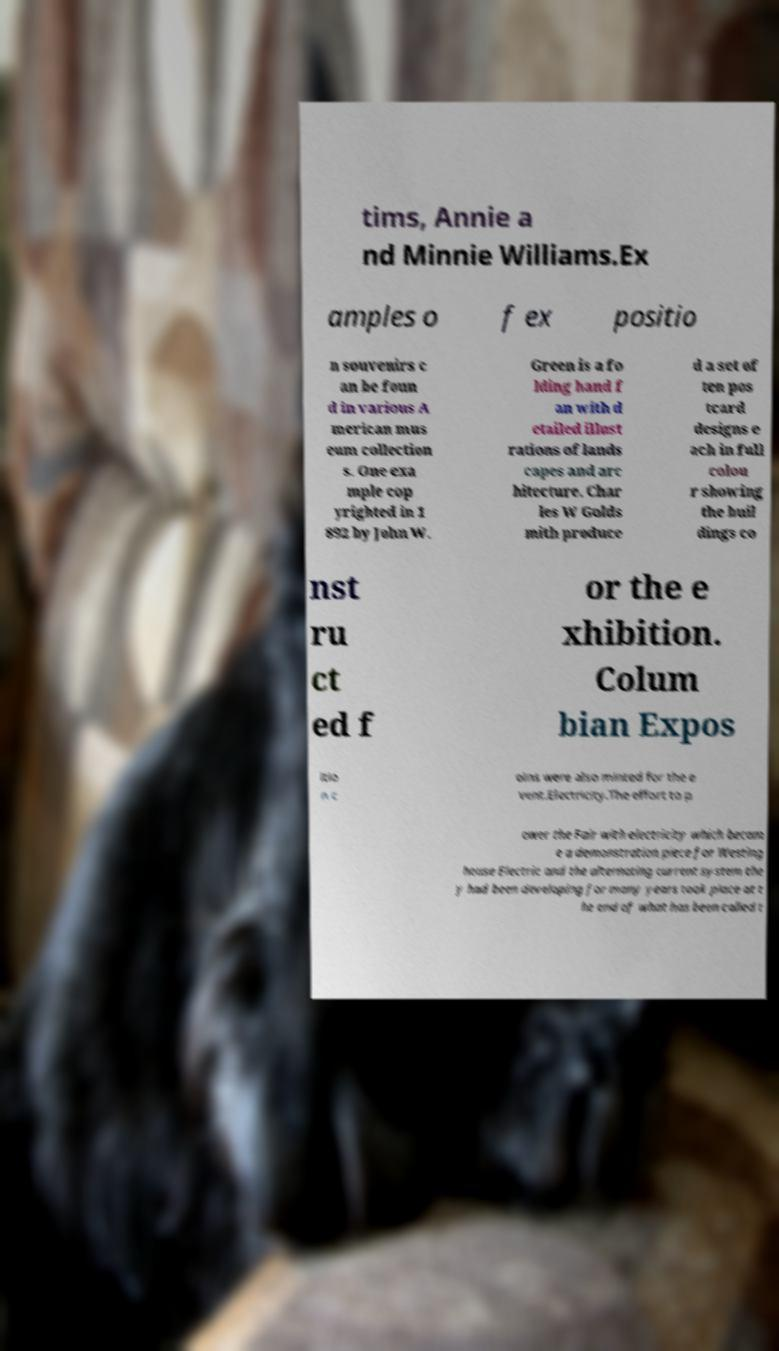Please read and relay the text visible in this image. What does it say? tims, Annie a nd Minnie Williams.Ex amples o f ex positio n souvenirs c an be foun d in various A merican mus eum collection s. One exa mple cop yrighted in 1 892 by John W. Green is a fo lding hand f an with d etailed illust rations of lands capes and arc hitecture. Char les W Golds mith produce d a set of ten pos tcard designs e ach in full colou r showing the buil dings co nst ru ct ed f or the e xhibition. Colum bian Expos itio n c oins were also minted for the e vent.Electricity.The effort to p ower the Fair with electricity which becam e a demonstration piece for Westing house Electric and the alternating current system the y had been developing for many years took place at t he end of what has been called t 